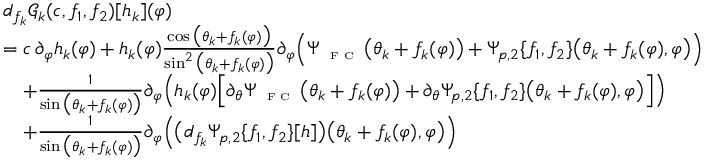Convert formula to latex. <formula><loc_0><loc_0><loc_500><loc_500>\begin{array} { r l } & { d _ { f _ { k } } \ m a t h s c r { G } _ { k } ( c , f _ { 1 } , f _ { 2 } ) [ h _ { k } ] ( \varphi ) } \\ & { = c \, \partial _ { \varphi } h _ { k } ( \varphi ) + h _ { k } ( \varphi ) \frac { \cos \left ( \theta _ { k } + f _ { k } ( \varphi ) \right ) } { \sin ^ { 2 } \left ( \theta _ { k } + f _ { k } ( \varphi ) \right ) } \partial _ { \varphi } \left ( \Psi _ { F C } \left ( \theta _ { k } + f _ { k } ( \varphi ) \right ) + \Psi _ { p , 2 } \{ f _ { 1 } , f _ { 2 } \} \left ( \theta _ { k } + f _ { k } ( \varphi ) , \varphi \right ) \right ) } \\ & { \quad + \frac { 1 } { \sin \left ( \theta _ { k } + f _ { k } ( \varphi ) \right ) } \partial _ { \varphi } \left ( h _ { k } ( \varphi ) \left [ \partial _ { \theta } \Psi _ { F C } \left ( \theta _ { k } + f _ { k } ( \varphi ) \right ) + \partial _ { \theta } \Psi _ { p , 2 } \{ f _ { 1 } , f _ { 2 } \} \left ( \theta _ { k } + f _ { k } ( \varphi ) , \varphi \right ) \right ] \right ) } \\ & { \quad + \frac { 1 } { \sin \left ( \theta _ { k } + f _ { k } ( \varphi ) \right ) } \partial _ { \varphi } \left ( \left ( d _ { f _ { k } } \Psi _ { p , 2 } \{ f _ { 1 } , f _ { 2 } \} [ h ] \right ) \left ( \theta _ { k } + f _ { k } ( \varphi ) , \varphi \right ) \right ) } \end{array}</formula> 